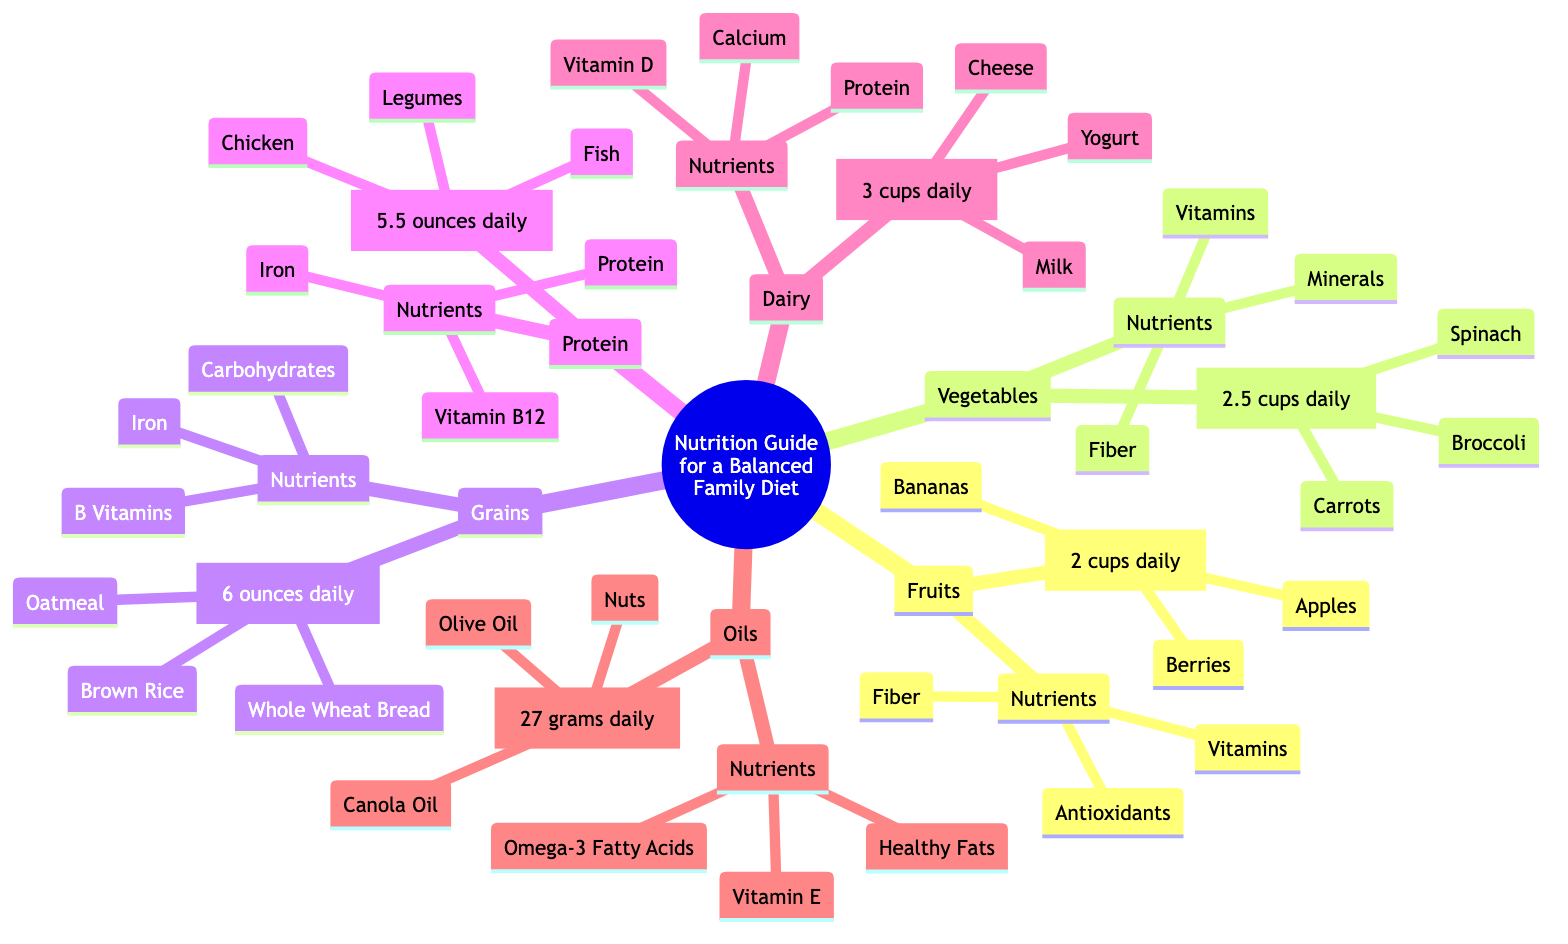What is the recommended daily intake for Fruits? The diagram shows that the recommended daily intake for Fruits is indicated right next to the Fruits node as 2 cups daily.
Answer: 2 cups daily How many ounces of Protein are recommended daily? The daily recommendation for Protein is provided next to the Protein node, which states 5.5 ounces daily.
Answer: 5.5 ounces daily What nutrients are found in Vegetables? Under the Vegetables node, the nutrients listed include Vitamins, Minerals, and Fiber. These are specified in their respective section.
Answer: Vitamins, Minerals, Fiber Which food group has the highest daily intake recommendation? By comparing the values provided by each food group, Grains shows the highest recommended intake at 6 ounces daily.
Answer: Grains What is the combined daily intake for Dairy and Oils? The daily intake for Dairy is 3 cups daily, and for Oils, it is 27 grams daily. To combine them, we must refer to the food groups without needing to convert them into the same unit. Therefore, the combined daily intakes are just added as they are stated: 3 cups daily and 27 grams daily.
Answer: 3 cups daily and 27 grams daily Which food group includes legumes? The food group that includes legumes is Protein as listed in that section.
Answer: Protein What nutrients do Grains provide? Under the Grains node, it specifies that the nutrients provided are Carbohydrates, B Vitamins, and Iron.
Answer: Carbohydrates, B Vitamins, Iron Is Olive Oil a part of the Dairy group? Looking at the diagram, Olive Oil is listed under the Oils section, not Dairy, indicating it is a different food group altogether.
Answer: No How many total food groups are mentioned in the diagram? The diagram lists six distinct food groups: Fruits, Vegetables, Grains, Protein, Dairy, and Oils, summarizing them without any overlapped representation.
Answer: 6 